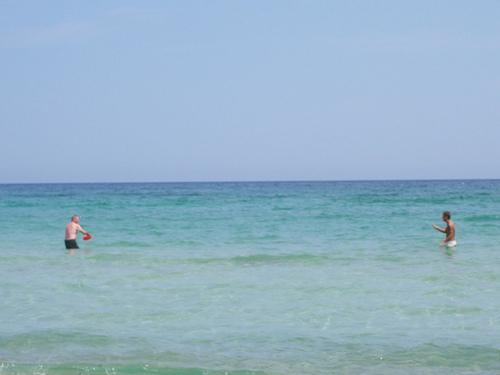Why does the man in white have his arm out? catch frisbee 